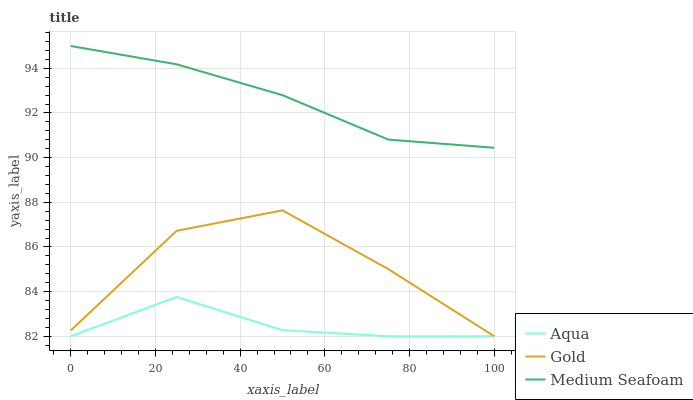Does Aqua have the minimum area under the curve?
Answer yes or no. Yes. Does Medium Seafoam have the maximum area under the curve?
Answer yes or no. Yes. Does Gold have the minimum area under the curve?
Answer yes or no. No. Does Gold have the maximum area under the curve?
Answer yes or no. No. Is Medium Seafoam the smoothest?
Answer yes or no. Yes. Is Gold the roughest?
Answer yes or no. Yes. Is Gold the smoothest?
Answer yes or no. No. Is Medium Seafoam the roughest?
Answer yes or no. No. Does Aqua have the lowest value?
Answer yes or no. Yes. Does Medium Seafoam have the lowest value?
Answer yes or no. No. Does Medium Seafoam have the highest value?
Answer yes or no. Yes. Does Gold have the highest value?
Answer yes or no. No. Is Aqua less than Medium Seafoam?
Answer yes or no. Yes. Is Medium Seafoam greater than Gold?
Answer yes or no. Yes. Does Aqua intersect Gold?
Answer yes or no. Yes. Is Aqua less than Gold?
Answer yes or no. No. Is Aqua greater than Gold?
Answer yes or no. No. Does Aqua intersect Medium Seafoam?
Answer yes or no. No. 